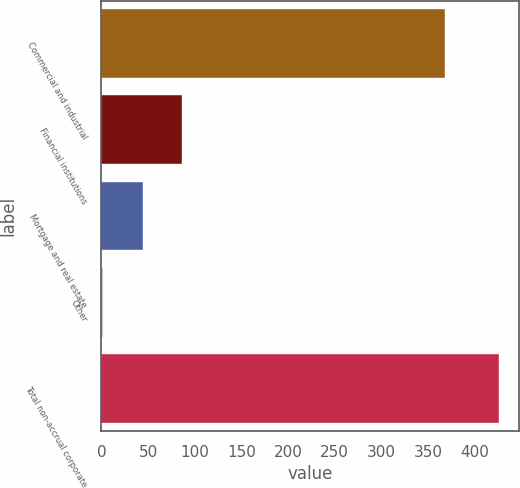Convert chart to OTSL. <chart><loc_0><loc_0><loc_500><loc_500><bar_chart><fcel>Commercial and industrial<fcel>Financial institutions<fcel>Mortgage and real estate<fcel>Other<fcel>Total non-accrual corporate<nl><fcel>368<fcel>86.8<fcel>44.4<fcel>2<fcel>426<nl></chart> 